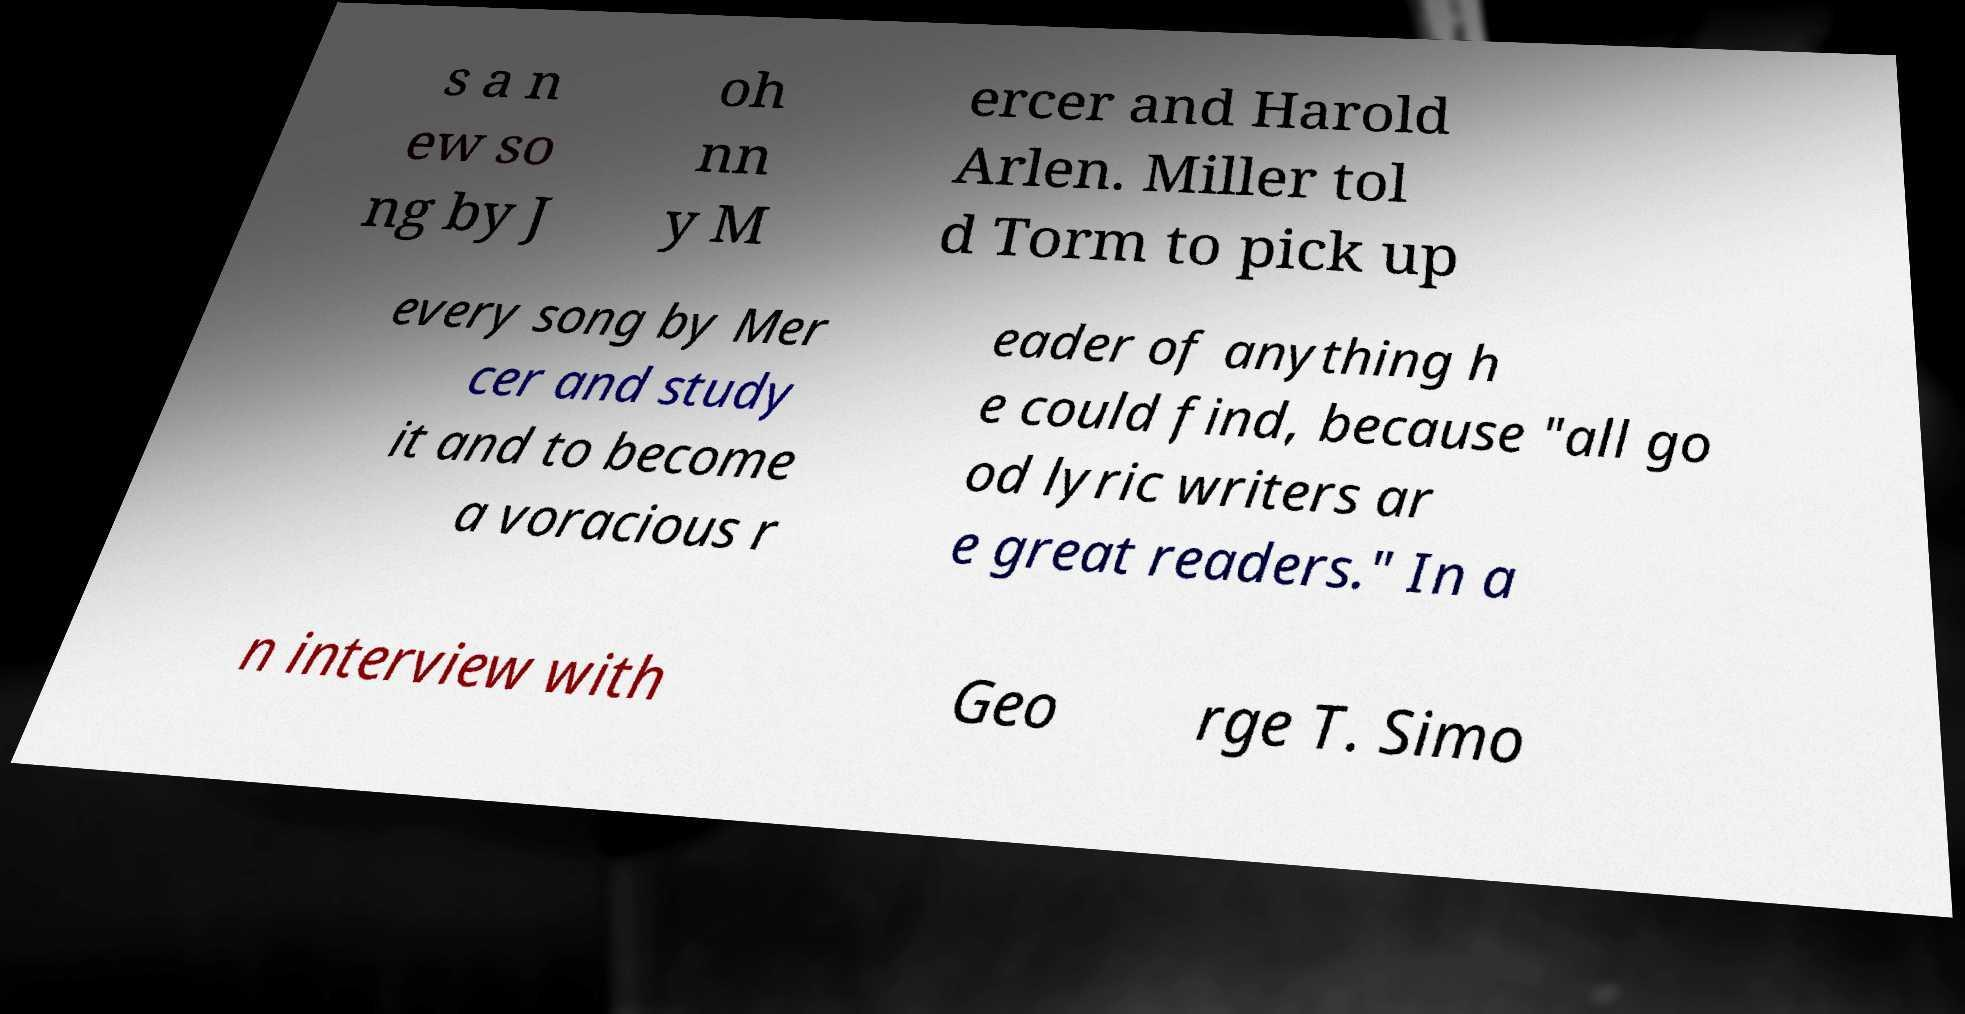Can you read and provide the text displayed in the image?This photo seems to have some interesting text. Can you extract and type it out for me? s a n ew so ng by J oh nn y M ercer and Harold Arlen. Miller tol d Torm to pick up every song by Mer cer and study it and to become a voracious r eader of anything h e could find, because "all go od lyric writers ar e great readers." In a n interview with Geo rge T. Simo 